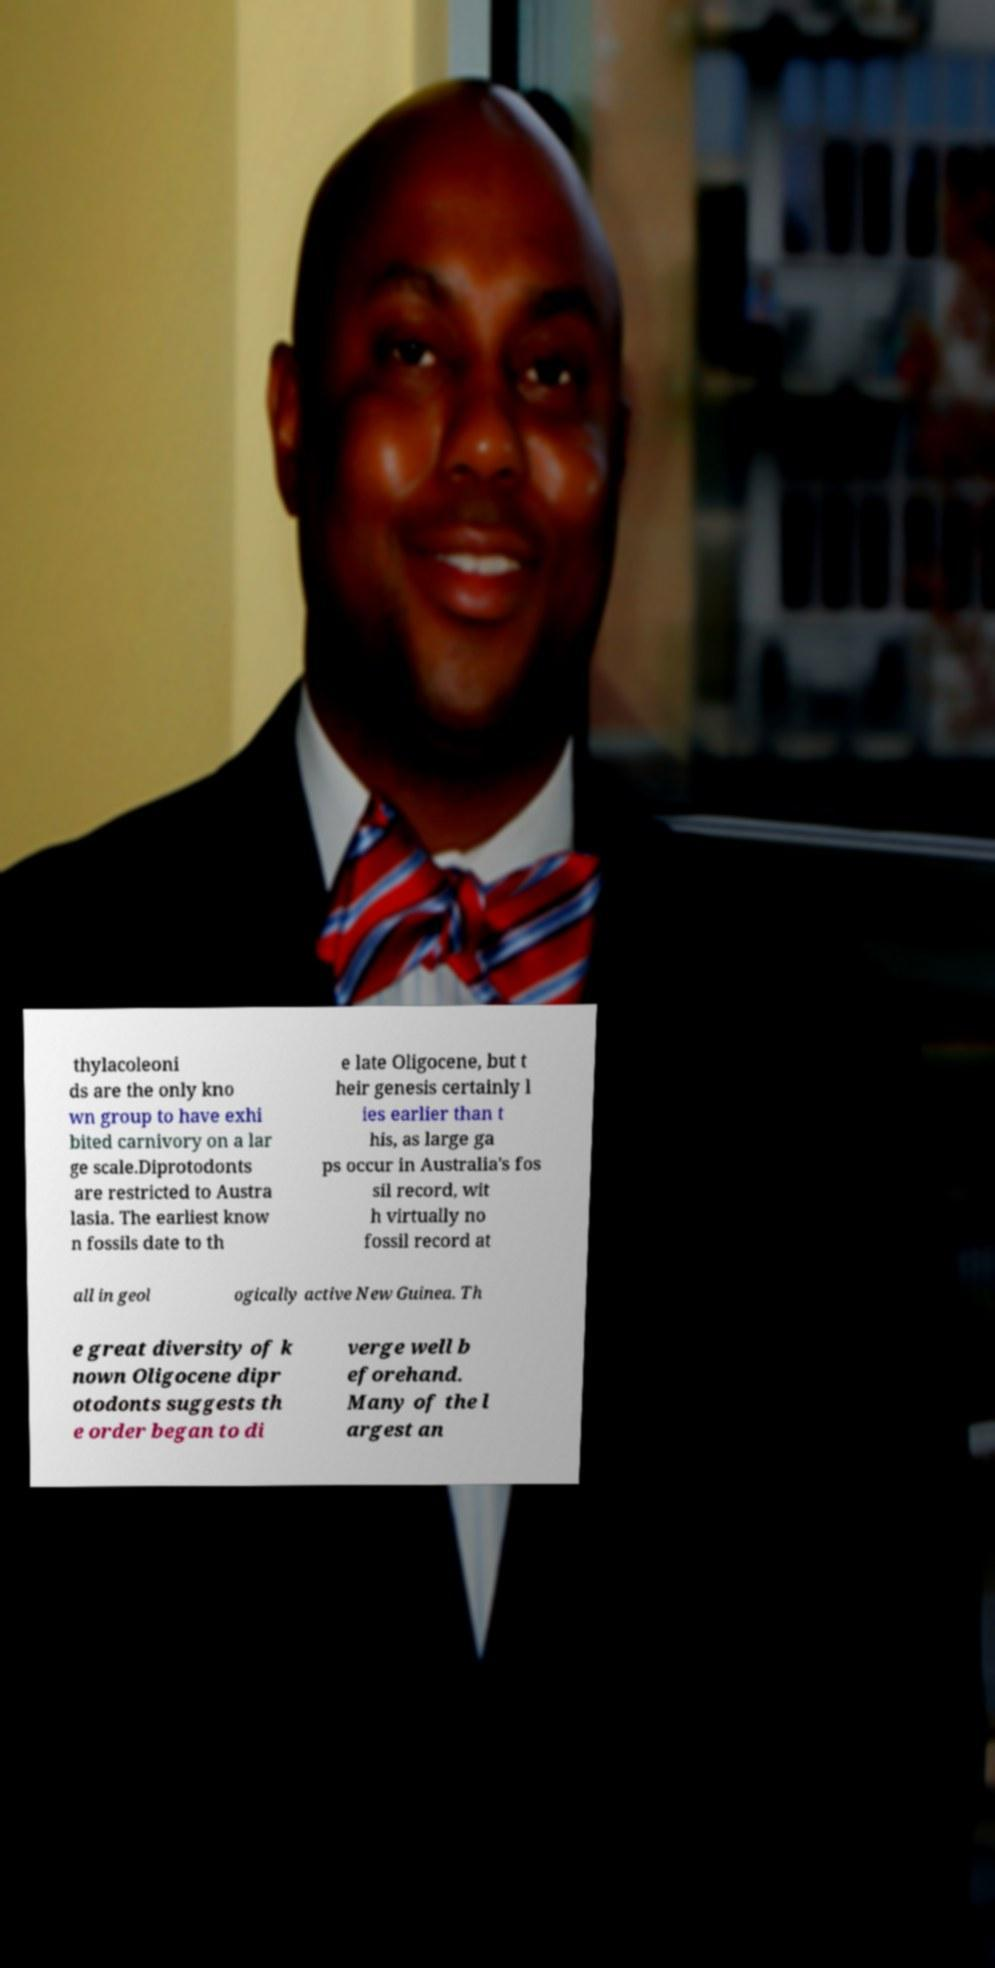Can you accurately transcribe the text from the provided image for me? thylacoleoni ds are the only kno wn group to have exhi bited carnivory on a lar ge scale.Diprotodonts are restricted to Austra lasia. The earliest know n fossils date to th e late Oligocene, but t heir genesis certainly l ies earlier than t his, as large ga ps occur in Australia's fos sil record, wit h virtually no fossil record at all in geol ogically active New Guinea. Th e great diversity of k nown Oligocene dipr otodonts suggests th e order began to di verge well b eforehand. Many of the l argest an 